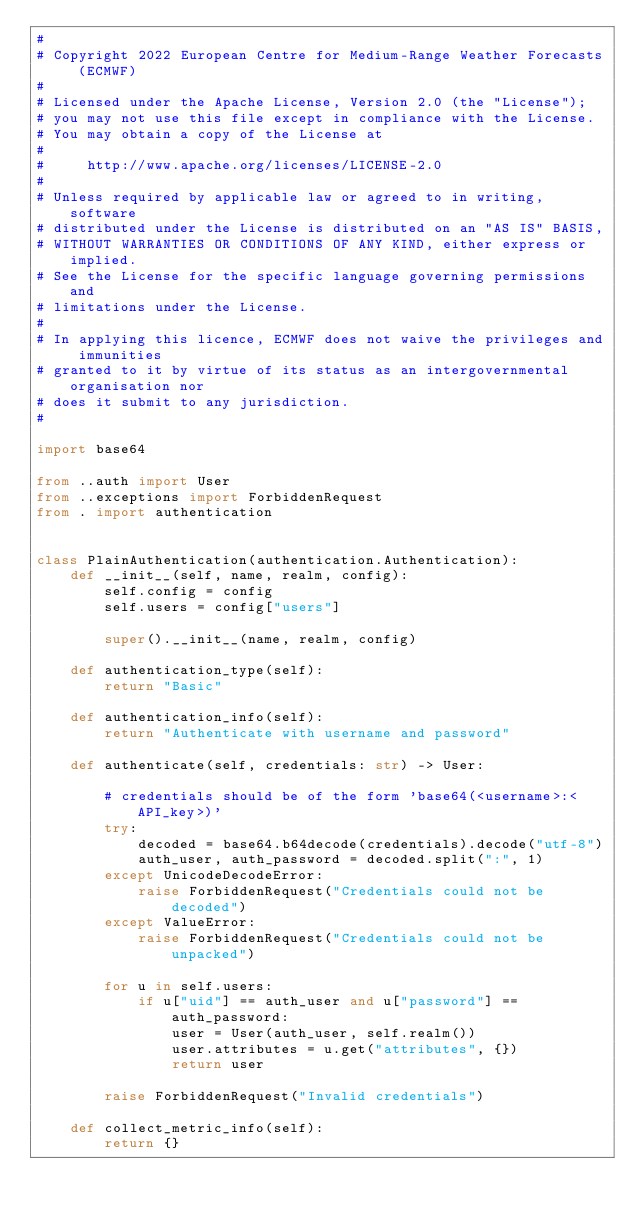Convert code to text. <code><loc_0><loc_0><loc_500><loc_500><_Python_>#
# Copyright 2022 European Centre for Medium-Range Weather Forecasts (ECMWF)
#
# Licensed under the Apache License, Version 2.0 (the "License");
# you may not use this file except in compliance with the License.
# You may obtain a copy of the License at
#
#     http://www.apache.org/licenses/LICENSE-2.0
#
# Unless required by applicable law or agreed to in writing, software
# distributed under the License is distributed on an "AS IS" BASIS,
# WITHOUT WARRANTIES OR CONDITIONS OF ANY KIND, either express or implied.
# See the License for the specific language governing permissions and
# limitations under the License.
#
# In applying this licence, ECMWF does not waive the privileges and immunities
# granted to it by virtue of its status as an intergovernmental organisation nor
# does it submit to any jurisdiction.
#

import base64

from ..auth import User
from ..exceptions import ForbiddenRequest
from . import authentication


class PlainAuthentication(authentication.Authentication):
    def __init__(self, name, realm, config):
        self.config = config
        self.users = config["users"]

        super().__init__(name, realm, config)

    def authentication_type(self):
        return "Basic"

    def authentication_info(self):
        return "Authenticate with username and password"

    def authenticate(self, credentials: str) -> User:

        # credentials should be of the form 'base64(<username>:<API_key>)'
        try:
            decoded = base64.b64decode(credentials).decode("utf-8")
            auth_user, auth_password = decoded.split(":", 1)
        except UnicodeDecodeError:
            raise ForbiddenRequest("Credentials could not be decoded")
        except ValueError:
            raise ForbiddenRequest("Credentials could not be unpacked")

        for u in self.users:
            if u["uid"] == auth_user and u["password"] == auth_password:
                user = User(auth_user, self.realm())
                user.attributes = u.get("attributes", {})
                return user

        raise ForbiddenRequest("Invalid credentials")

    def collect_metric_info(self):
        return {}
</code> 